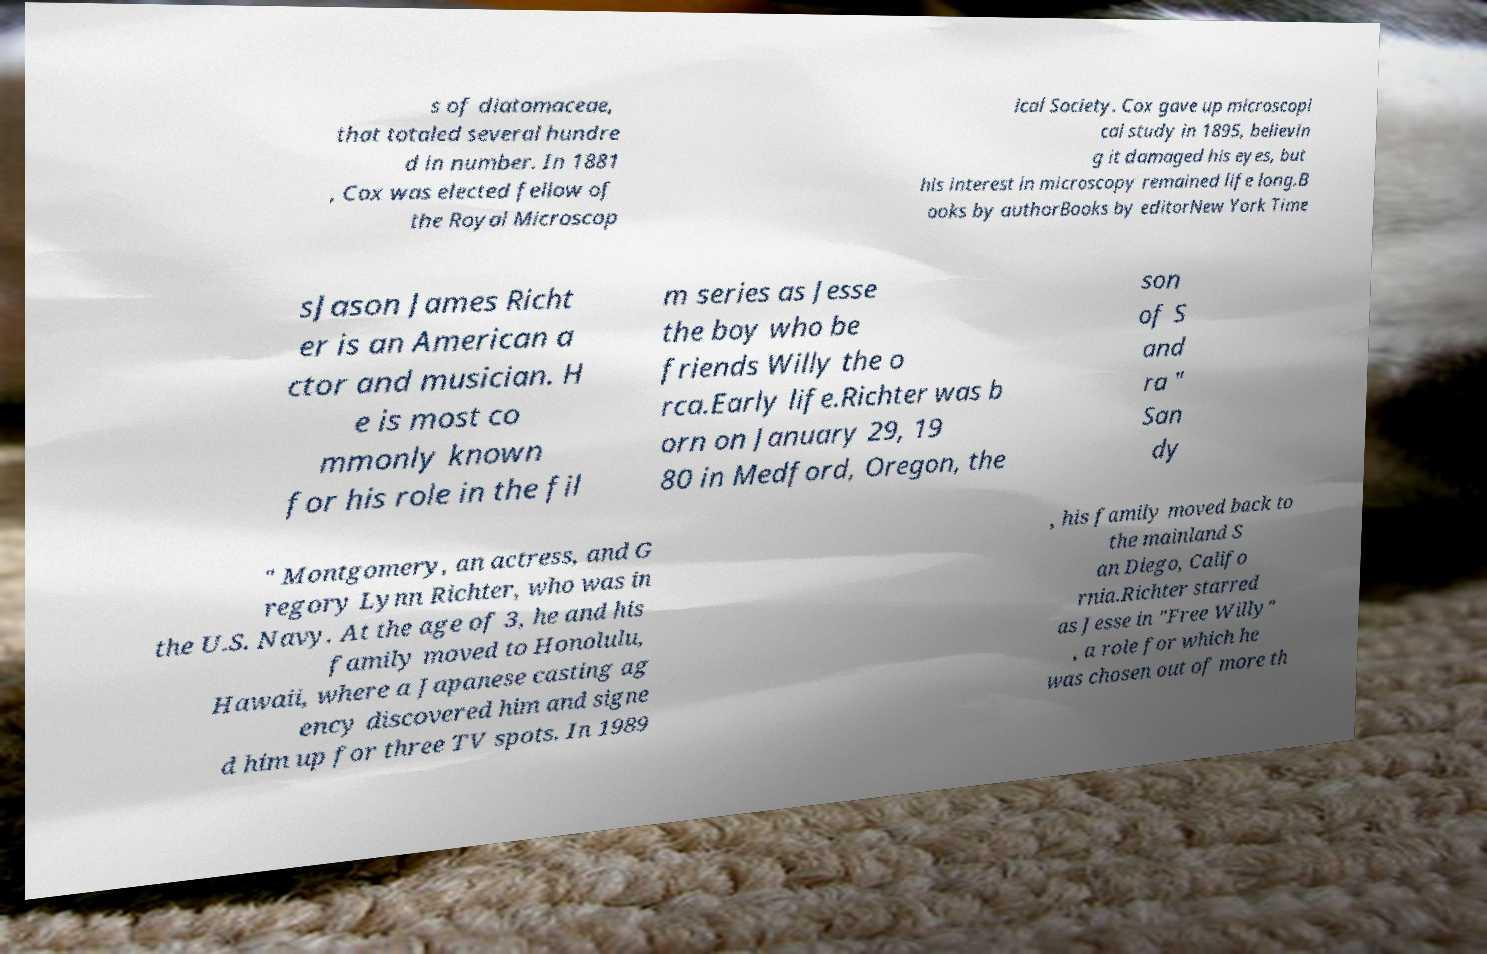I need the written content from this picture converted into text. Can you do that? s of diatomaceae, that totaled several hundre d in number. In 1881 , Cox was elected fellow of the Royal Microscop ical Society. Cox gave up microscopi cal study in 1895, believin g it damaged his eyes, but his interest in microscopy remained life long.B ooks by authorBooks by editorNew York Time sJason James Richt er is an American a ctor and musician. H e is most co mmonly known for his role in the fil m series as Jesse the boy who be friends Willy the o rca.Early life.Richter was b orn on January 29, 19 80 in Medford, Oregon, the son of S and ra " San dy " Montgomery, an actress, and G regory Lynn Richter, who was in the U.S. Navy. At the age of 3, he and his family moved to Honolulu, Hawaii, where a Japanese casting ag ency discovered him and signe d him up for three TV spots. In 1989 , his family moved back to the mainland S an Diego, Califo rnia.Richter starred as Jesse in "Free Willy" , a role for which he was chosen out of more th 